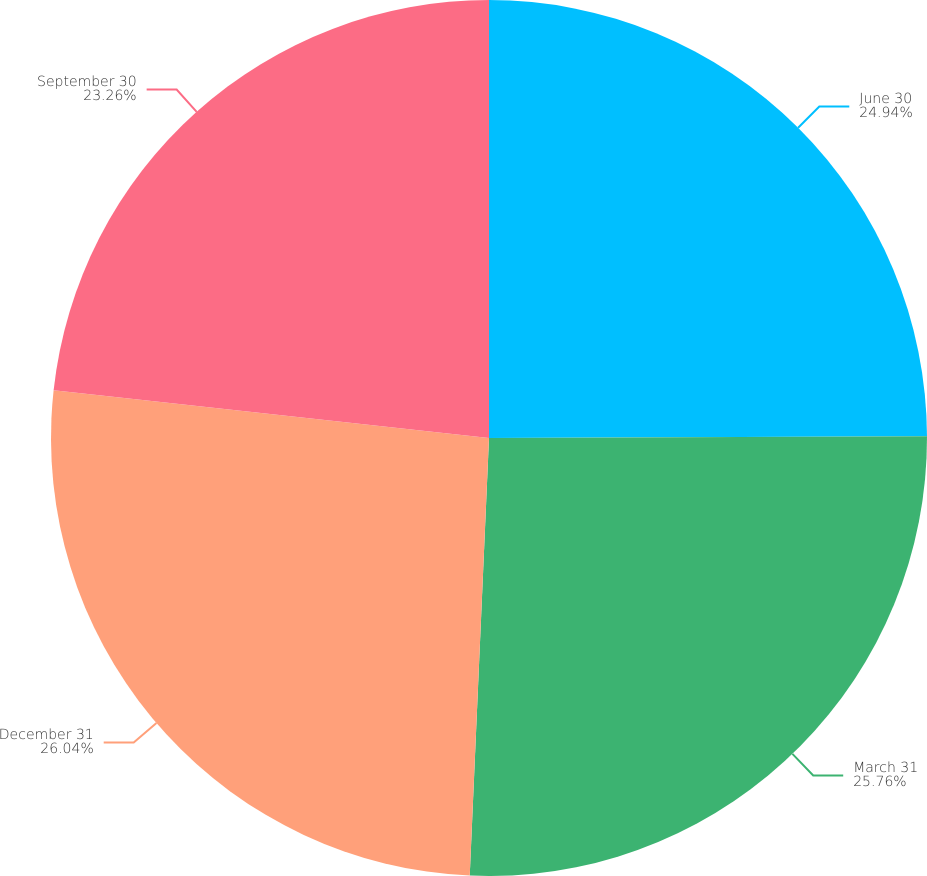<chart> <loc_0><loc_0><loc_500><loc_500><pie_chart><fcel>June 30<fcel>March 31<fcel>December 31<fcel>September 30<nl><fcel>24.94%<fcel>25.76%<fcel>26.04%<fcel>23.26%<nl></chart> 